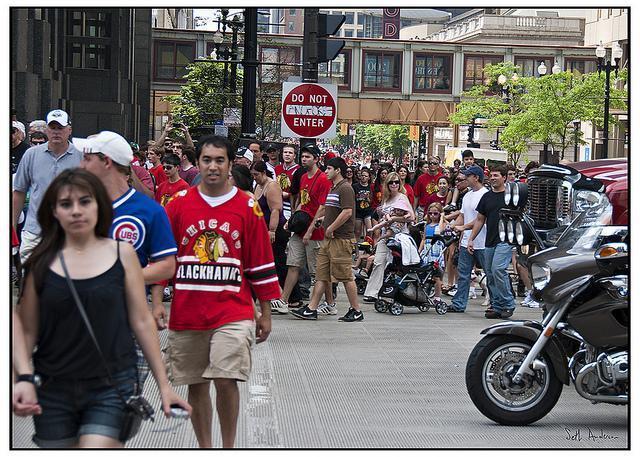Who captains the team of the jersey in red?
Make your selection from the four choices given to correctly answer the question.
Options: Mario iginla, jonathan toes, lionel messi, bill reid. Jonathan toes. 